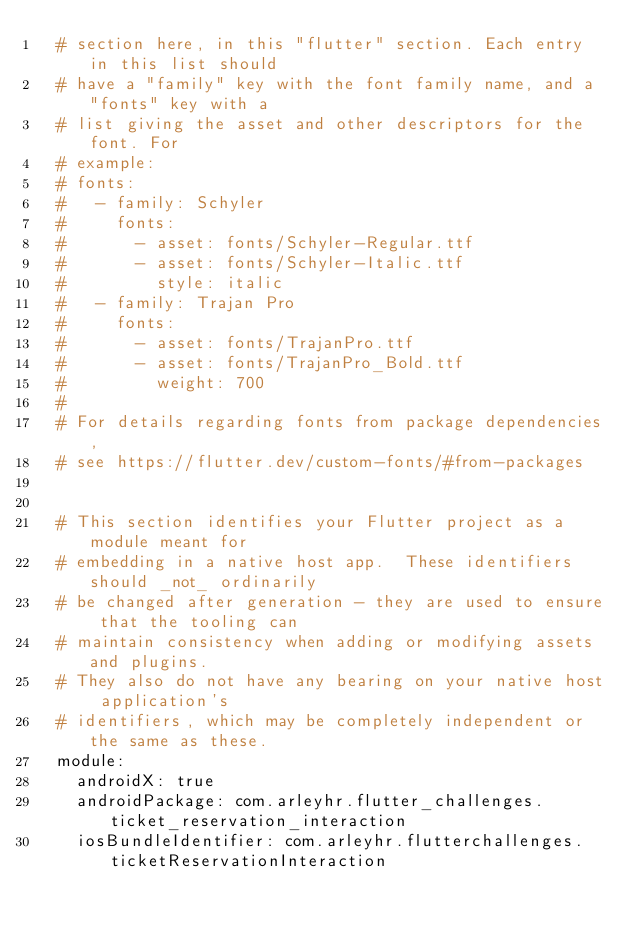Convert code to text. <code><loc_0><loc_0><loc_500><loc_500><_YAML_>  # section here, in this "flutter" section. Each entry in this list should
  # have a "family" key with the font family name, and a "fonts" key with a
  # list giving the asset and other descriptors for the font. For
  # example:
  # fonts:
  #   - family: Schyler
  #     fonts:
  #       - asset: fonts/Schyler-Regular.ttf
  #       - asset: fonts/Schyler-Italic.ttf
  #         style: italic
  #   - family: Trajan Pro
  #     fonts:
  #       - asset: fonts/TrajanPro.ttf
  #       - asset: fonts/TrajanPro_Bold.ttf
  #         weight: 700
  #
  # For details regarding fonts from package dependencies,
  # see https://flutter.dev/custom-fonts/#from-packages


  # This section identifies your Flutter project as a module meant for
  # embedding in a native host app.  These identifiers should _not_ ordinarily
  # be changed after generation - they are used to ensure that the tooling can
  # maintain consistency when adding or modifying assets and plugins.
  # They also do not have any bearing on your native host application's
  # identifiers, which may be completely independent or the same as these.
  module:
    androidX: true
    androidPackage: com.arleyhr.flutter_challenges.ticket_reservation_interaction
    iosBundleIdentifier: com.arleyhr.flutterchallenges.ticketReservationInteraction
</code> 